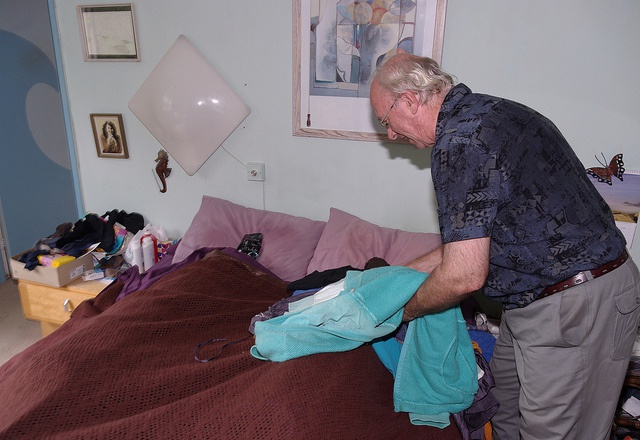Describe the objects in this image and their specific colors. I can see bed in gray, maroon, black, and brown tones and people in gray and black tones in this image. 